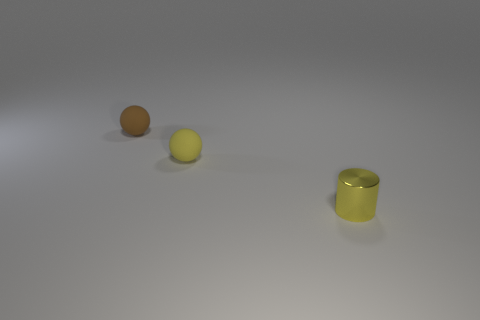How many objects are things behind the yellow metallic thing or tiny matte things on the right side of the brown sphere?
Your answer should be compact. 2. What is the material of the other thing that is the same shape as the yellow rubber thing?
Provide a succinct answer. Rubber. What number of metal things are small spheres or tiny brown objects?
Your answer should be compact. 0. What is the shape of the small yellow thing that is made of the same material as the brown ball?
Ensure brevity in your answer.  Sphere. What number of other small objects have the same shape as the small yellow rubber thing?
Offer a terse response. 1. Is the shape of the matte thing to the left of the small yellow rubber sphere the same as the yellow thing behind the yellow metallic cylinder?
Offer a very short reply. Yes. How many things are either brown objects or yellow things that are behind the yellow metallic thing?
Offer a terse response. 2. How many brown rubber spheres have the same size as the yellow matte sphere?
Offer a very short reply. 1. What number of yellow things are either tiny shiny spheres or small rubber balls?
Provide a short and direct response. 1. What is the shape of the matte thing to the left of the yellow thing that is to the left of the small metal cylinder?
Your answer should be compact. Sphere. 